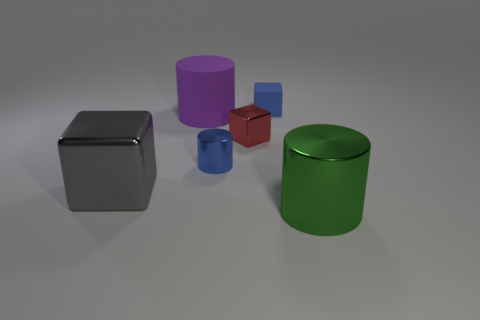There is a tiny red thing that is the same shape as the blue rubber thing; what is it made of?
Offer a terse response. Metal. How many cubes are either rubber objects or gray metallic things?
Offer a terse response. 2. How many blue things have the same material as the gray cube?
Ensure brevity in your answer.  1. Are the big green cylinder that is on the right side of the large gray thing and the block left of the big purple rubber cylinder made of the same material?
Make the answer very short. Yes. There is a big shiny thing that is behind the large metal thing in front of the gray shiny cube; how many blue metallic objects are left of it?
Keep it short and to the point. 0. There is a shiny cylinder that is left of the matte cube; is it the same color as the large metallic object behind the big green metal cylinder?
Your response must be concise. No. Are there any other things that are the same color as the small matte thing?
Make the answer very short. Yes. What color is the matte object that is behind the large cylinder that is behind the red block?
Offer a terse response. Blue. Is there a small red rubber sphere?
Give a very brief answer. No. What color is the metallic thing that is on the right side of the small blue metallic cylinder and behind the large gray thing?
Keep it short and to the point. Red. 